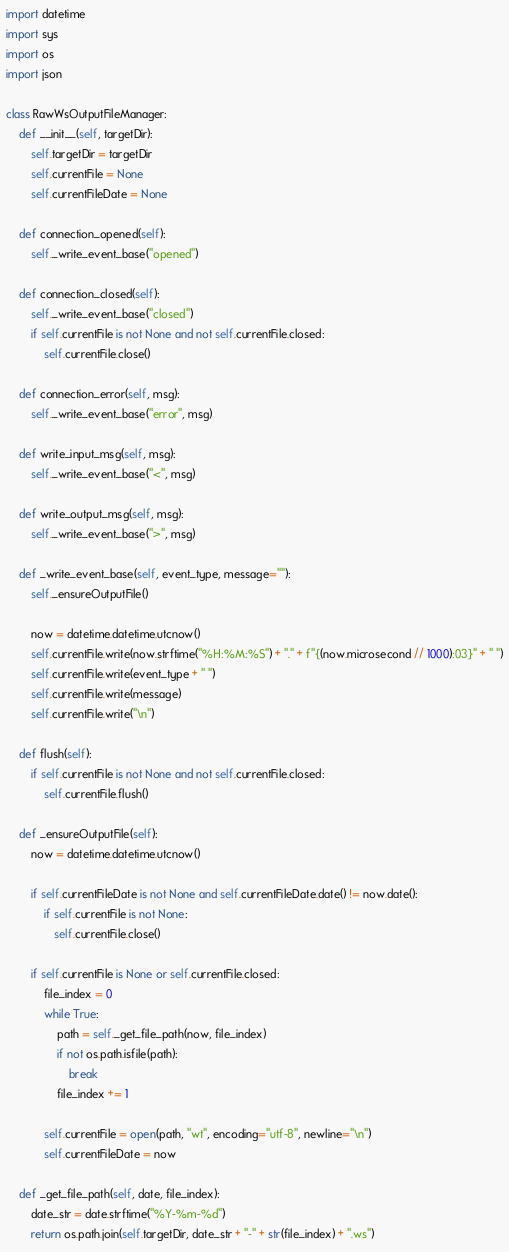<code> <loc_0><loc_0><loc_500><loc_500><_Python_>import datetime
import sys
import os
import json

class RawWsOutputFileManager:
    def __init__(self, targetDir):
        self.targetDir = targetDir
        self.currentFile = None
        self.currentFileDate = None
    
    def connection_opened(self):
        self._write_event_base("opened")
        
    def connection_closed(self):
        self._write_event_base("closed")
        if self.currentFile is not None and not self.currentFile.closed:
            self.currentFile.close()
        
    def connection_error(self, msg):
        self._write_event_base("error", msg)
    
    def write_input_msg(self, msg):
        self._write_event_base("<", msg)
    
    def write_output_msg(self, msg):
        self._write_event_base(">", msg)

    def _write_event_base(self, event_type, message=""):
        self._ensureOutputFile()

        now = datetime.datetime.utcnow()
        self.currentFile.write(now.strftime("%H:%M:%S") + "." + f"{(now.microsecond // 1000):03}" + " ")
        self.currentFile.write(event_type + " ")
        self.currentFile.write(message)
        self.currentFile.write("\n")
        
    def flush(self):
        if self.currentFile is not None and not self.currentFile.closed:
            self.currentFile.flush()
        
    def _ensureOutputFile(self):
        now = datetime.datetime.utcnow()

        if self.currentFileDate is not None and self.currentFileDate.date() != now.date():
            if self.currentFile is not None:
               self.currentFile.close()

        if self.currentFile is None or self.currentFile.closed:
            file_index = 0
            while True:
                path = self._get_file_path(now, file_index)
                if not os.path.isfile(path):
                    break
                file_index += 1

            self.currentFile = open(path, "wt", encoding="utf-8", newline="\n")
            self.currentFileDate = now
            
    def _get_file_path(self, date, file_index):
        date_str = date.strftime("%Y-%m-%d")
        return os.path.join(self.targetDir, date_str + "-" + str(file_index) + ".ws")</code> 